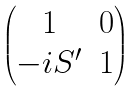Convert formula to latex. <formula><loc_0><loc_0><loc_500><loc_500>\begin{pmatrix} 1 & 0 \\ - i S ^ { \prime } & 1 \end{pmatrix}</formula> 